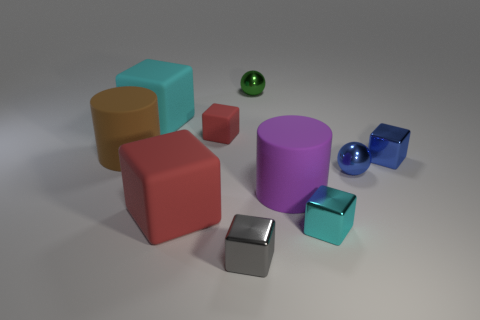Is there a metallic cube that is in front of the red cube that is in front of the tiny metal cube behind the purple cylinder?
Provide a succinct answer. Yes. Is the number of tiny green metal things that are in front of the big red rubber block greater than the number of cyan rubber blocks?
Give a very brief answer. No. Is the shape of the tiny metal thing behind the large brown matte thing the same as  the tiny matte thing?
Keep it short and to the point. No. How many objects are tiny shiny things or tiny balls that are to the left of the small blue metallic sphere?
Offer a very short reply. 5. There is a object that is both to the left of the tiny red matte cube and behind the tiny red block; how big is it?
Make the answer very short. Large. Are there more objects to the right of the tiny green metal object than red matte blocks that are behind the brown cylinder?
Offer a very short reply. Yes. There is a purple object; does it have the same shape as the large brown matte object that is on the left side of the purple thing?
Your answer should be very brief. Yes. What number of other objects are there of the same shape as the big red matte object?
Make the answer very short. 5. The thing that is both behind the small matte object and to the left of the big red rubber cube is what color?
Provide a succinct answer. Cyan. The small matte object has what color?
Provide a succinct answer. Red. 